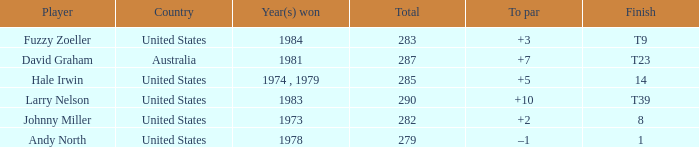Which player finished at +10? Larry Nelson. 